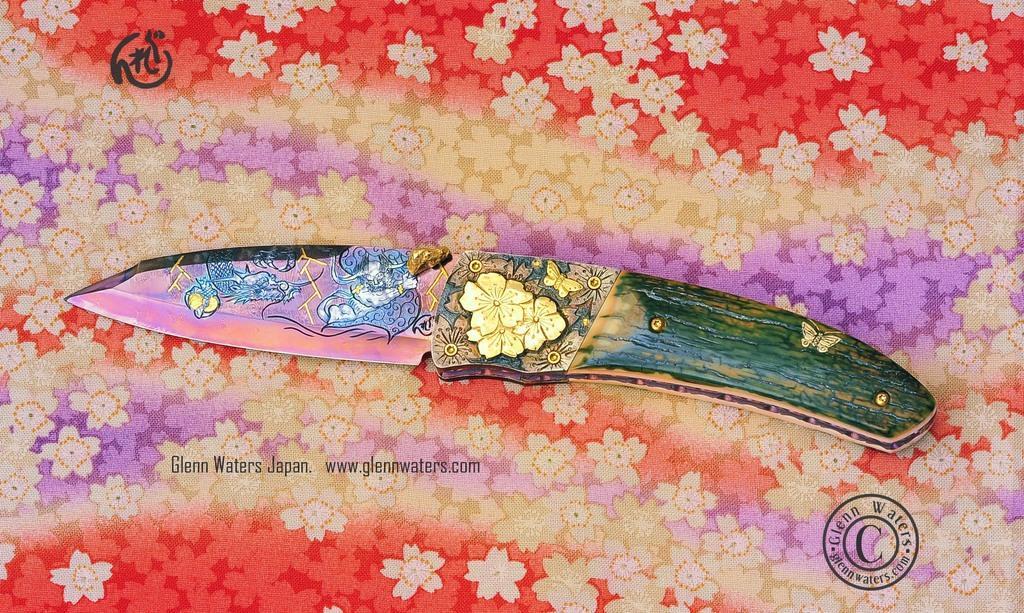In one or two sentences, can you explain what this image depicts? On the bottom right, there is a watermark. On the left side, there is another watermark. In the middle of this image, there is a knife placed on a cloth, which is having paintings of flowers and other designs. 